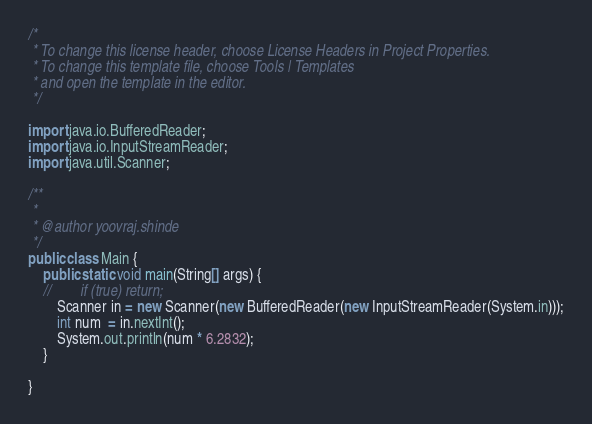Convert code to text. <code><loc_0><loc_0><loc_500><loc_500><_Java_>/*
 * To change this license header, choose License Headers in Project Properties.
 * To change this template file, choose Tools | Templates
 * and open the template in the editor.
 */

import java.io.BufferedReader;
import java.io.InputStreamReader;
import java.util.Scanner;

/**
 *
 * @author yoovraj.shinde
 */
public class Main {
    public static void main(String[] args) {
    //        if (true) return;
        Scanner in = new Scanner(new BufferedReader(new InputStreamReader(System.in)));
        int num  = in.nextInt();
        System.out.println(num * 6.2832);
    }

}
</code> 